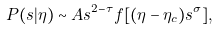<formula> <loc_0><loc_0><loc_500><loc_500>P ( s | \eta ) \sim A s ^ { 2 - \tau } f [ ( \eta - \eta _ { c } ) s ^ { \sigma } ] ,</formula> 